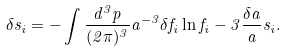<formula> <loc_0><loc_0><loc_500><loc_500>\delta s _ { i } = - \int \frac { d ^ { 3 } p } { ( 2 \pi ) ^ { 3 } } a ^ { - 3 } \delta f _ { i } \ln f _ { i } - 3 \frac { \delta a } { a } s _ { i } .</formula> 